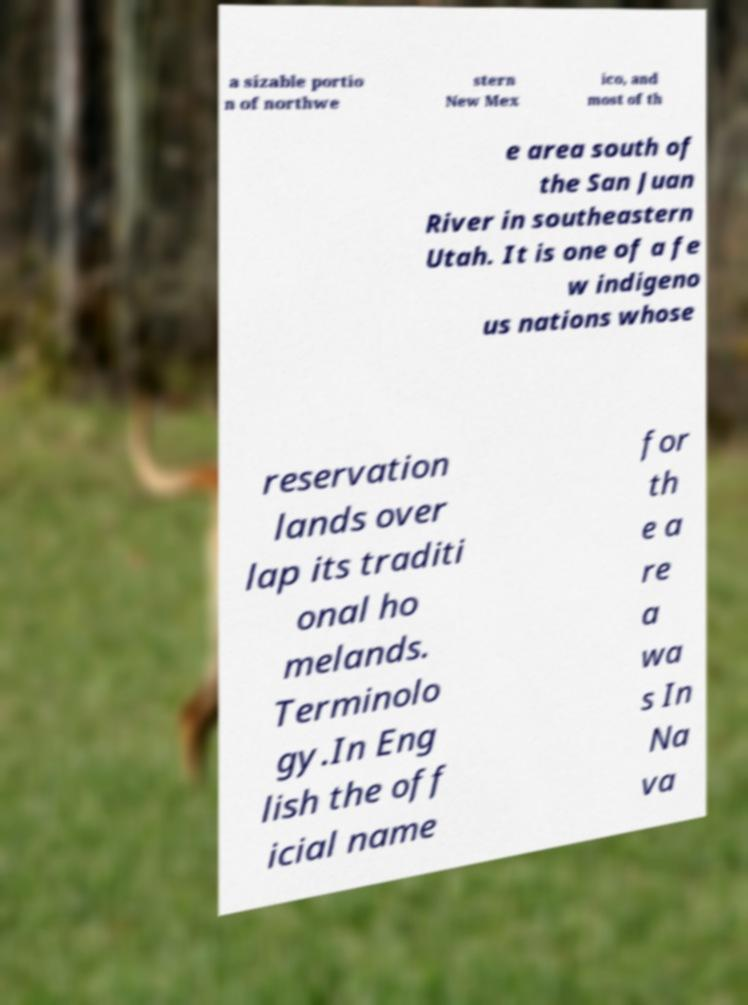Could you assist in decoding the text presented in this image and type it out clearly? a sizable portio n of northwe stern New Mex ico, and most of th e area south of the San Juan River in southeastern Utah. It is one of a fe w indigeno us nations whose reservation lands over lap its traditi onal ho melands. Terminolo gy.In Eng lish the off icial name for th e a re a wa s In Na va 